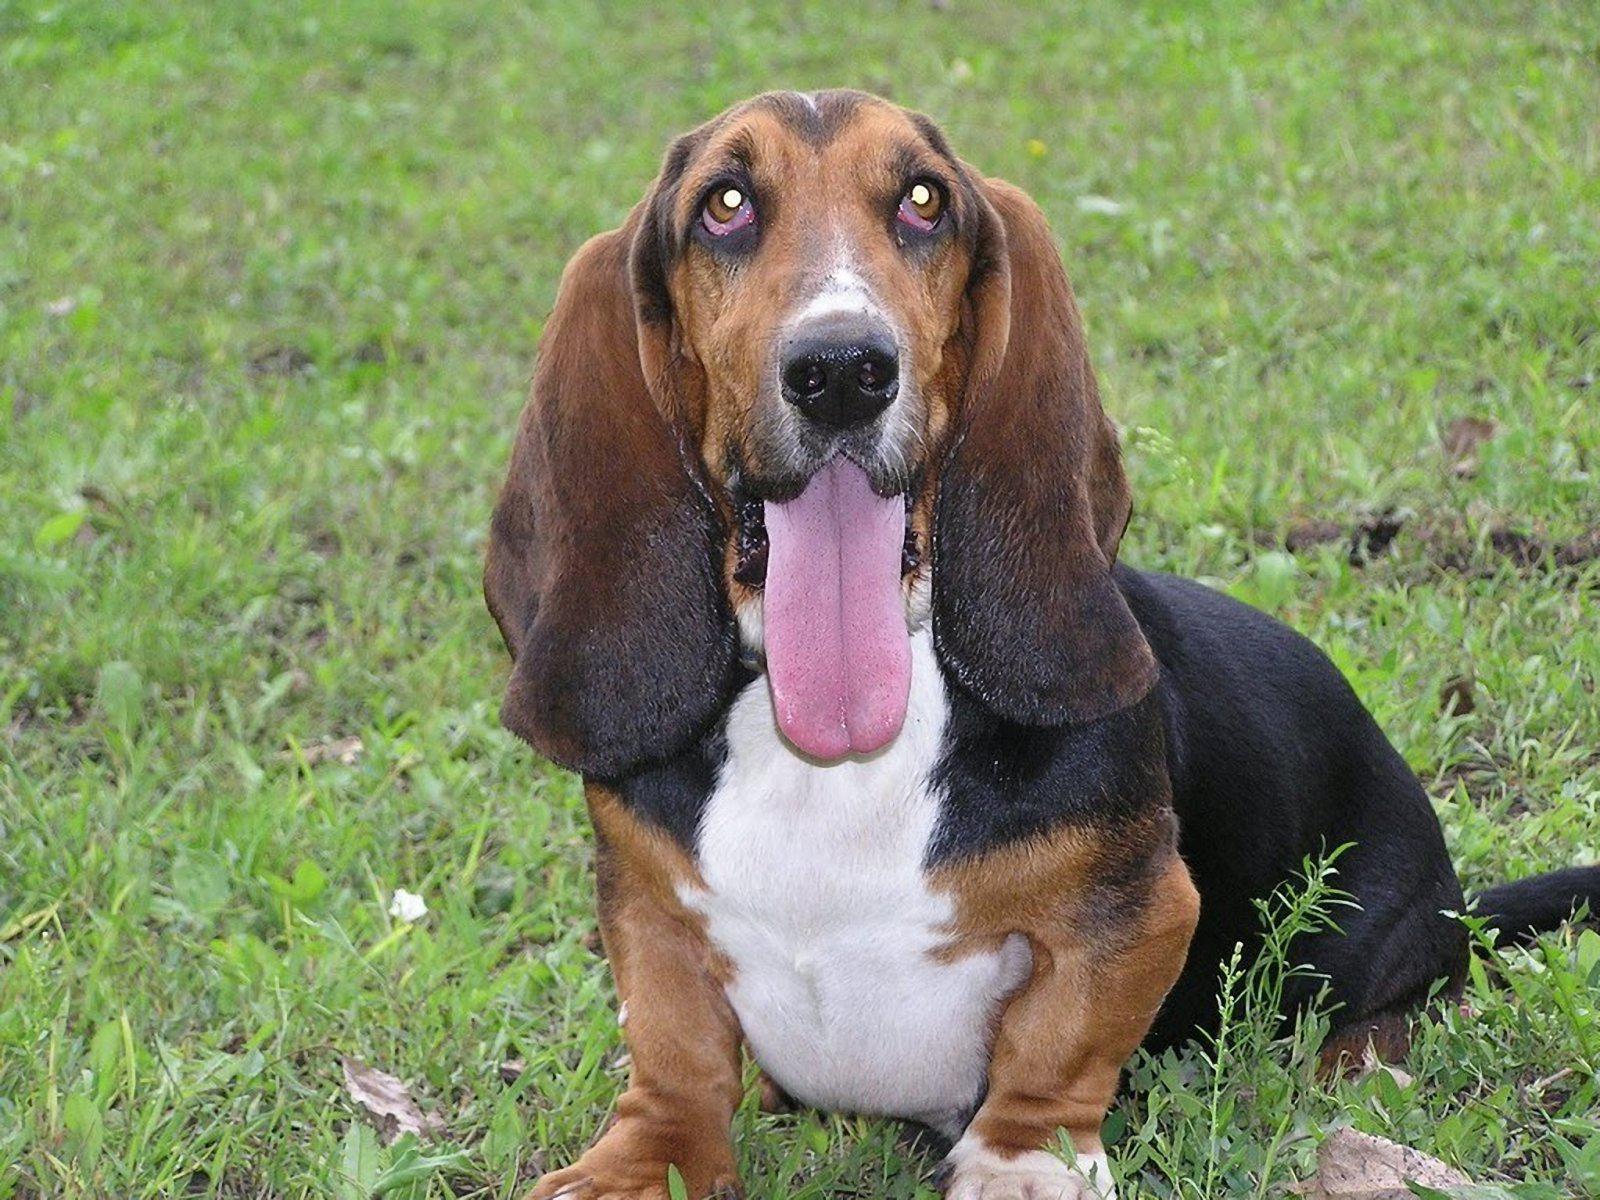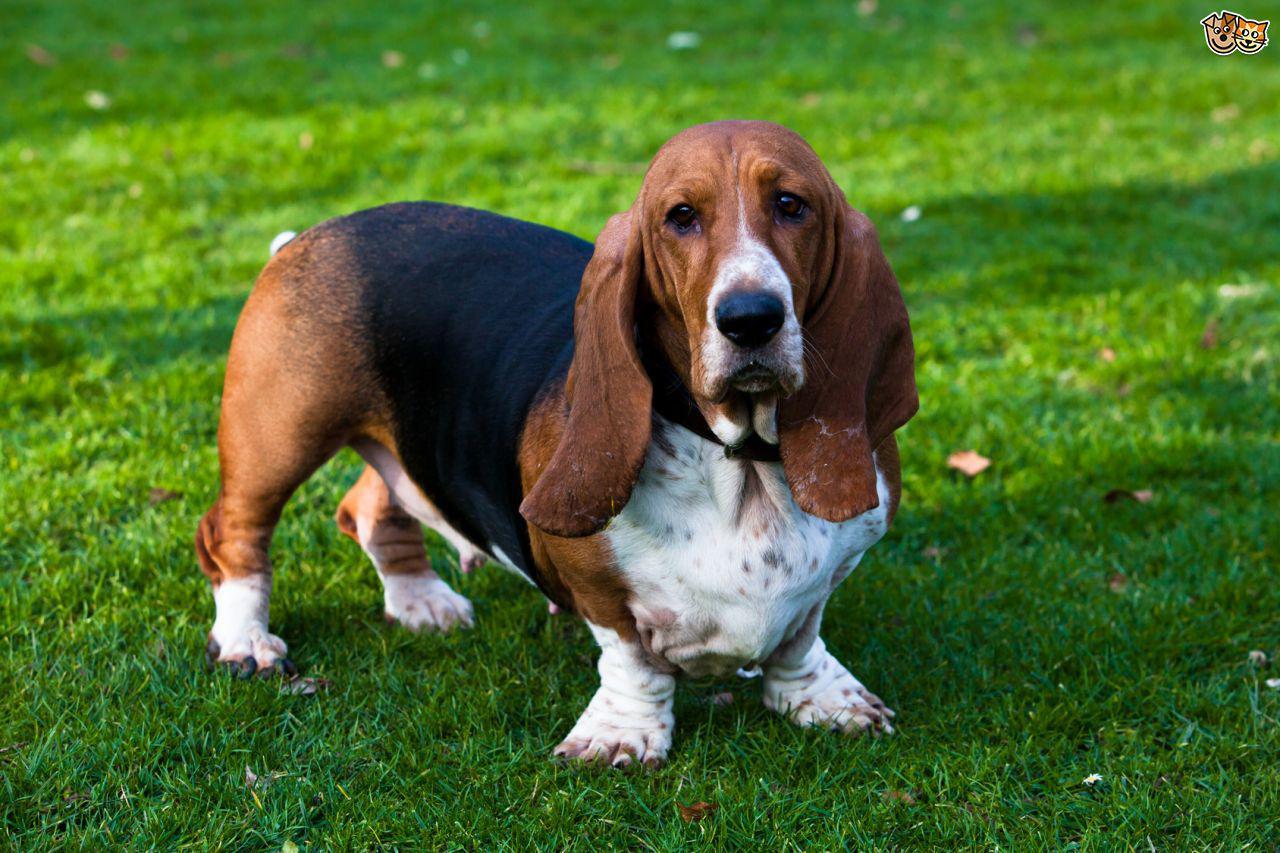The first image is the image on the left, the second image is the image on the right. Analyze the images presented: Is the assertion "A dogs tongue is sticking way out." valid? Answer yes or no. Yes. The first image is the image on the left, the second image is the image on the right. Evaluate the accuracy of this statement regarding the images: "A basset hound is showing its tongue in exactly one of the photos.". Is it true? Answer yes or no. Yes. 